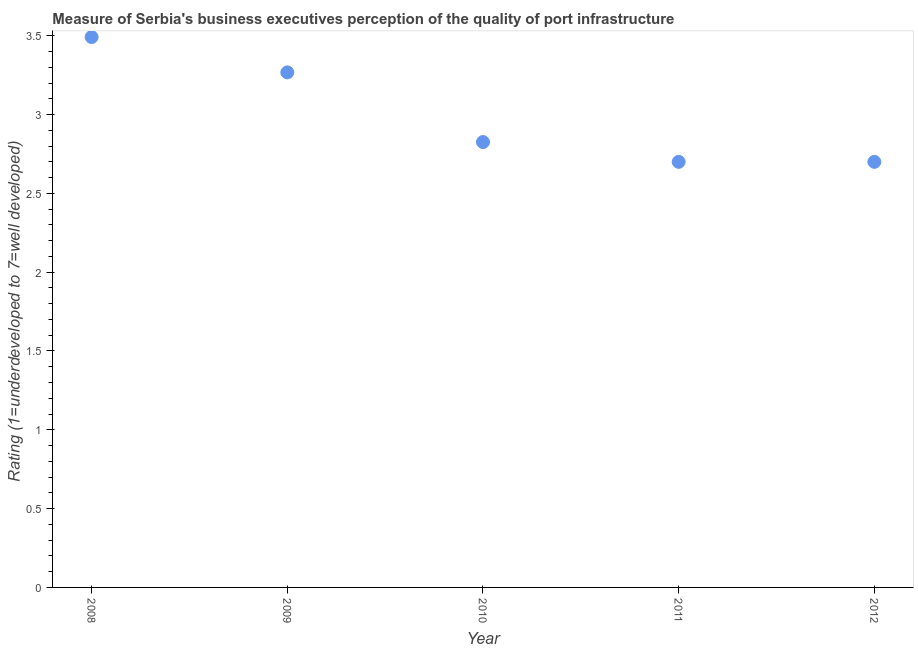What is the rating measuring quality of port infrastructure in 2010?
Make the answer very short. 2.83. Across all years, what is the maximum rating measuring quality of port infrastructure?
Keep it short and to the point. 3.49. Across all years, what is the minimum rating measuring quality of port infrastructure?
Keep it short and to the point. 2.7. In which year was the rating measuring quality of port infrastructure maximum?
Make the answer very short. 2008. In which year was the rating measuring quality of port infrastructure minimum?
Your response must be concise. 2011. What is the sum of the rating measuring quality of port infrastructure?
Offer a terse response. 14.99. What is the difference between the rating measuring quality of port infrastructure in 2009 and 2011?
Ensure brevity in your answer.  0.57. What is the average rating measuring quality of port infrastructure per year?
Give a very brief answer. 3. What is the median rating measuring quality of port infrastructure?
Give a very brief answer. 2.83. Do a majority of the years between 2011 and 2010 (inclusive) have rating measuring quality of port infrastructure greater than 1.4 ?
Your answer should be very brief. No. What is the ratio of the rating measuring quality of port infrastructure in 2008 to that in 2010?
Give a very brief answer. 1.24. Is the rating measuring quality of port infrastructure in 2008 less than that in 2010?
Provide a short and direct response. No. Is the difference between the rating measuring quality of port infrastructure in 2010 and 2011 greater than the difference between any two years?
Provide a short and direct response. No. What is the difference between the highest and the second highest rating measuring quality of port infrastructure?
Offer a very short reply. 0.22. What is the difference between the highest and the lowest rating measuring quality of port infrastructure?
Make the answer very short. 0.79. In how many years, is the rating measuring quality of port infrastructure greater than the average rating measuring quality of port infrastructure taken over all years?
Offer a very short reply. 2. How many dotlines are there?
Provide a succinct answer. 1. How many years are there in the graph?
Keep it short and to the point. 5. What is the difference between two consecutive major ticks on the Y-axis?
Your response must be concise. 0.5. Are the values on the major ticks of Y-axis written in scientific E-notation?
Make the answer very short. No. Does the graph contain any zero values?
Offer a very short reply. No. Does the graph contain grids?
Your response must be concise. No. What is the title of the graph?
Provide a succinct answer. Measure of Serbia's business executives perception of the quality of port infrastructure. What is the label or title of the Y-axis?
Make the answer very short. Rating (1=underdeveloped to 7=well developed) . What is the Rating (1=underdeveloped to 7=well developed)  in 2008?
Provide a short and direct response. 3.49. What is the Rating (1=underdeveloped to 7=well developed)  in 2009?
Provide a short and direct response. 3.27. What is the Rating (1=underdeveloped to 7=well developed)  in 2010?
Provide a succinct answer. 2.83. What is the difference between the Rating (1=underdeveloped to 7=well developed)  in 2008 and 2009?
Offer a terse response. 0.22. What is the difference between the Rating (1=underdeveloped to 7=well developed)  in 2008 and 2010?
Your answer should be compact. 0.67. What is the difference between the Rating (1=underdeveloped to 7=well developed)  in 2008 and 2011?
Provide a succinct answer. 0.79. What is the difference between the Rating (1=underdeveloped to 7=well developed)  in 2008 and 2012?
Your answer should be very brief. 0.79. What is the difference between the Rating (1=underdeveloped to 7=well developed)  in 2009 and 2010?
Your answer should be very brief. 0.44. What is the difference between the Rating (1=underdeveloped to 7=well developed)  in 2009 and 2011?
Your answer should be compact. 0.57. What is the difference between the Rating (1=underdeveloped to 7=well developed)  in 2009 and 2012?
Ensure brevity in your answer.  0.57. What is the difference between the Rating (1=underdeveloped to 7=well developed)  in 2010 and 2011?
Provide a succinct answer. 0.13. What is the difference between the Rating (1=underdeveloped to 7=well developed)  in 2010 and 2012?
Your answer should be compact. 0.13. What is the difference between the Rating (1=underdeveloped to 7=well developed)  in 2011 and 2012?
Keep it short and to the point. 0. What is the ratio of the Rating (1=underdeveloped to 7=well developed)  in 2008 to that in 2009?
Keep it short and to the point. 1.07. What is the ratio of the Rating (1=underdeveloped to 7=well developed)  in 2008 to that in 2010?
Provide a short and direct response. 1.24. What is the ratio of the Rating (1=underdeveloped to 7=well developed)  in 2008 to that in 2011?
Your answer should be very brief. 1.29. What is the ratio of the Rating (1=underdeveloped to 7=well developed)  in 2008 to that in 2012?
Your answer should be very brief. 1.29. What is the ratio of the Rating (1=underdeveloped to 7=well developed)  in 2009 to that in 2010?
Ensure brevity in your answer.  1.16. What is the ratio of the Rating (1=underdeveloped to 7=well developed)  in 2009 to that in 2011?
Keep it short and to the point. 1.21. What is the ratio of the Rating (1=underdeveloped to 7=well developed)  in 2009 to that in 2012?
Offer a terse response. 1.21. What is the ratio of the Rating (1=underdeveloped to 7=well developed)  in 2010 to that in 2011?
Offer a very short reply. 1.05. What is the ratio of the Rating (1=underdeveloped to 7=well developed)  in 2010 to that in 2012?
Provide a short and direct response. 1.05. 